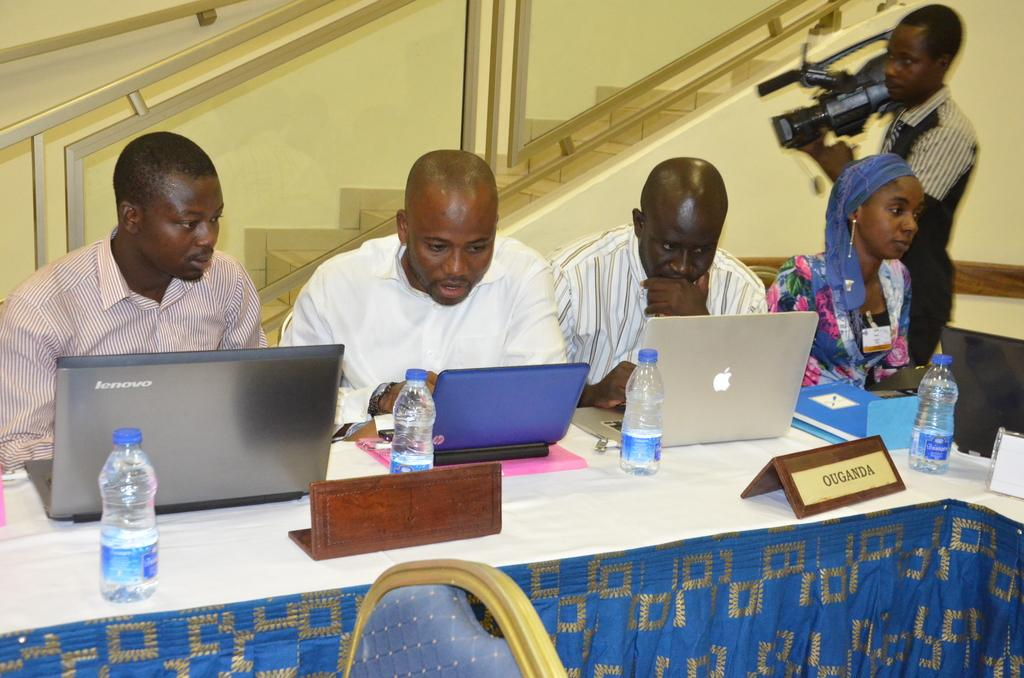Provide a one-sentence caption for the provided image. 3 men and 1 woman sitting at a table looking at laptops headed by a Mr Ouganda. 